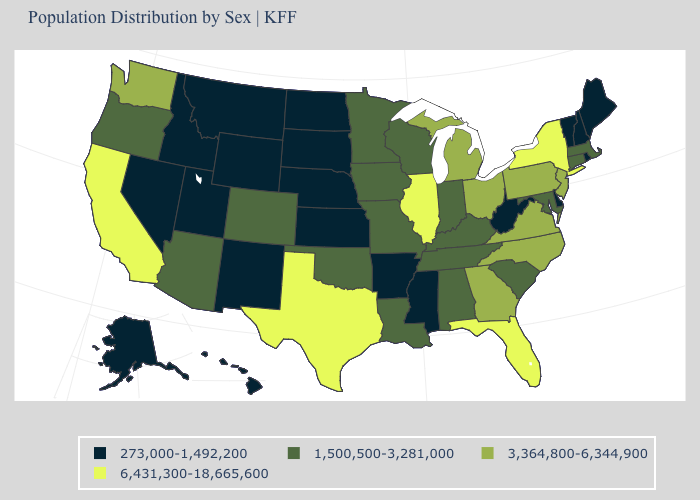Name the states that have a value in the range 1,500,500-3,281,000?
Keep it brief. Alabama, Arizona, Colorado, Connecticut, Indiana, Iowa, Kentucky, Louisiana, Maryland, Massachusetts, Minnesota, Missouri, Oklahoma, Oregon, South Carolina, Tennessee, Wisconsin. Which states have the lowest value in the West?
Short answer required. Alaska, Hawaii, Idaho, Montana, Nevada, New Mexico, Utah, Wyoming. What is the value of Ohio?
Be succinct. 3,364,800-6,344,900. Among the states that border Wyoming , which have the highest value?
Write a very short answer. Colorado. Which states hav the highest value in the MidWest?
Be succinct. Illinois. What is the value of New Jersey?
Short answer required. 3,364,800-6,344,900. What is the lowest value in states that border Louisiana?
Give a very brief answer. 273,000-1,492,200. Name the states that have a value in the range 3,364,800-6,344,900?
Answer briefly. Georgia, Michigan, New Jersey, North Carolina, Ohio, Pennsylvania, Virginia, Washington. What is the value of Massachusetts?
Keep it brief. 1,500,500-3,281,000. Does Pennsylvania have the highest value in the Northeast?
Quick response, please. No. Does the first symbol in the legend represent the smallest category?
Answer briefly. Yes. Is the legend a continuous bar?
Answer briefly. No. Name the states that have a value in the range 3,364,800-6,344,900?
Keep it brief. Georgia, Michigan, New Jersey, North Carolina, Ohio, Pennsylvania, Virginia, Washington. Name the states that have a value in the range 3,364,800-6,344,900?
Give a very brief answer. Georgia, Michigan, New Jersey, North Carolina, Ohio, Pennsylvania, Virginia, Washington. Which states hav the highest value in the Northeast?
Give a very brief answer. New York. 